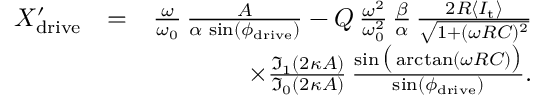<formula> <loc_0><loc_0><loc_500><loc_500>\begin{array} { r l r } { X _ { d r i v e } ^ { \prime } } & { = } & { \frac { \omega } { \omega _ { 0 } } \, \frac { A } { \alpha \, \sin ( \phi _ { d r i v e } ) } - Q \, \frac { \omega ^ { 2 } } { \omega _ { 0 } ^ { 2 } } \, \frac { \beta } { \alpha } \, \frac { 2 R \langle I _ { t } \rangle } { \sqrt { 1 + ( \omega R C ) ^ { 2 } } } } \\ & { \times \frac { \mathfrak { I } _ { 1 } ( 2 \kappa A ) } { \mathfrak { I } _ { 0 } ( 2 \kappa A ) } \, \frac { \sin \left ( \arctan ( \omega R C ) \right ) } { \sin ( \phi _ { d r i v e } ) } . } \end{array}</formula> 